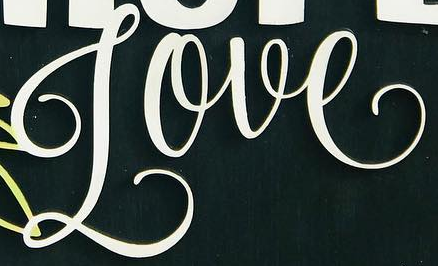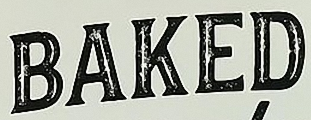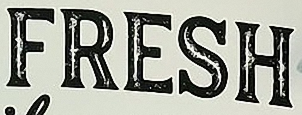What text appears in these images from left to right, separated by a semicolon? Love; BAKED; FRESH 